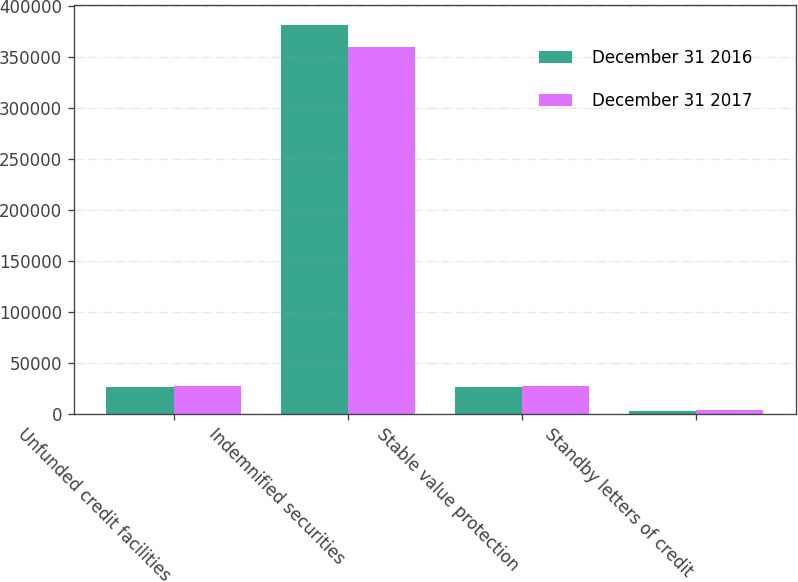<chart> <loc_0><loc_0><loc_500><loc_500><stacked_bar_chart><ecel><fcel>Unfunded credit facilities<fcel>Indemnified securities<fcel>Stable value protection<fcel>Standby letters of credit<nl><fcel>December 31 2016<fcel>26488<fcel>381817<fcel>26653<fcel>3158<nl><fcel>December 31 2017<fcel>26993<fcel>360452<fcel>27182<fcel>3459<nl></chart> 